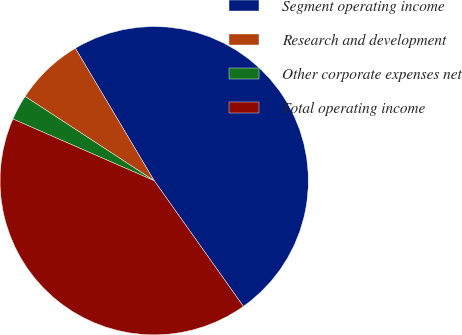Convert chart to OTSL. <chart><loc_0><loc_0><loc_500><loc_500><pie_chart><fcel>Segment operating income<fcel>Research and development<fcel>Other corporate expenses net<fcel>Total operating income<nl><fcel>48.72%<fcel>7.25%<fcel>2.65%<fcel>41.38%<nl></chart> 